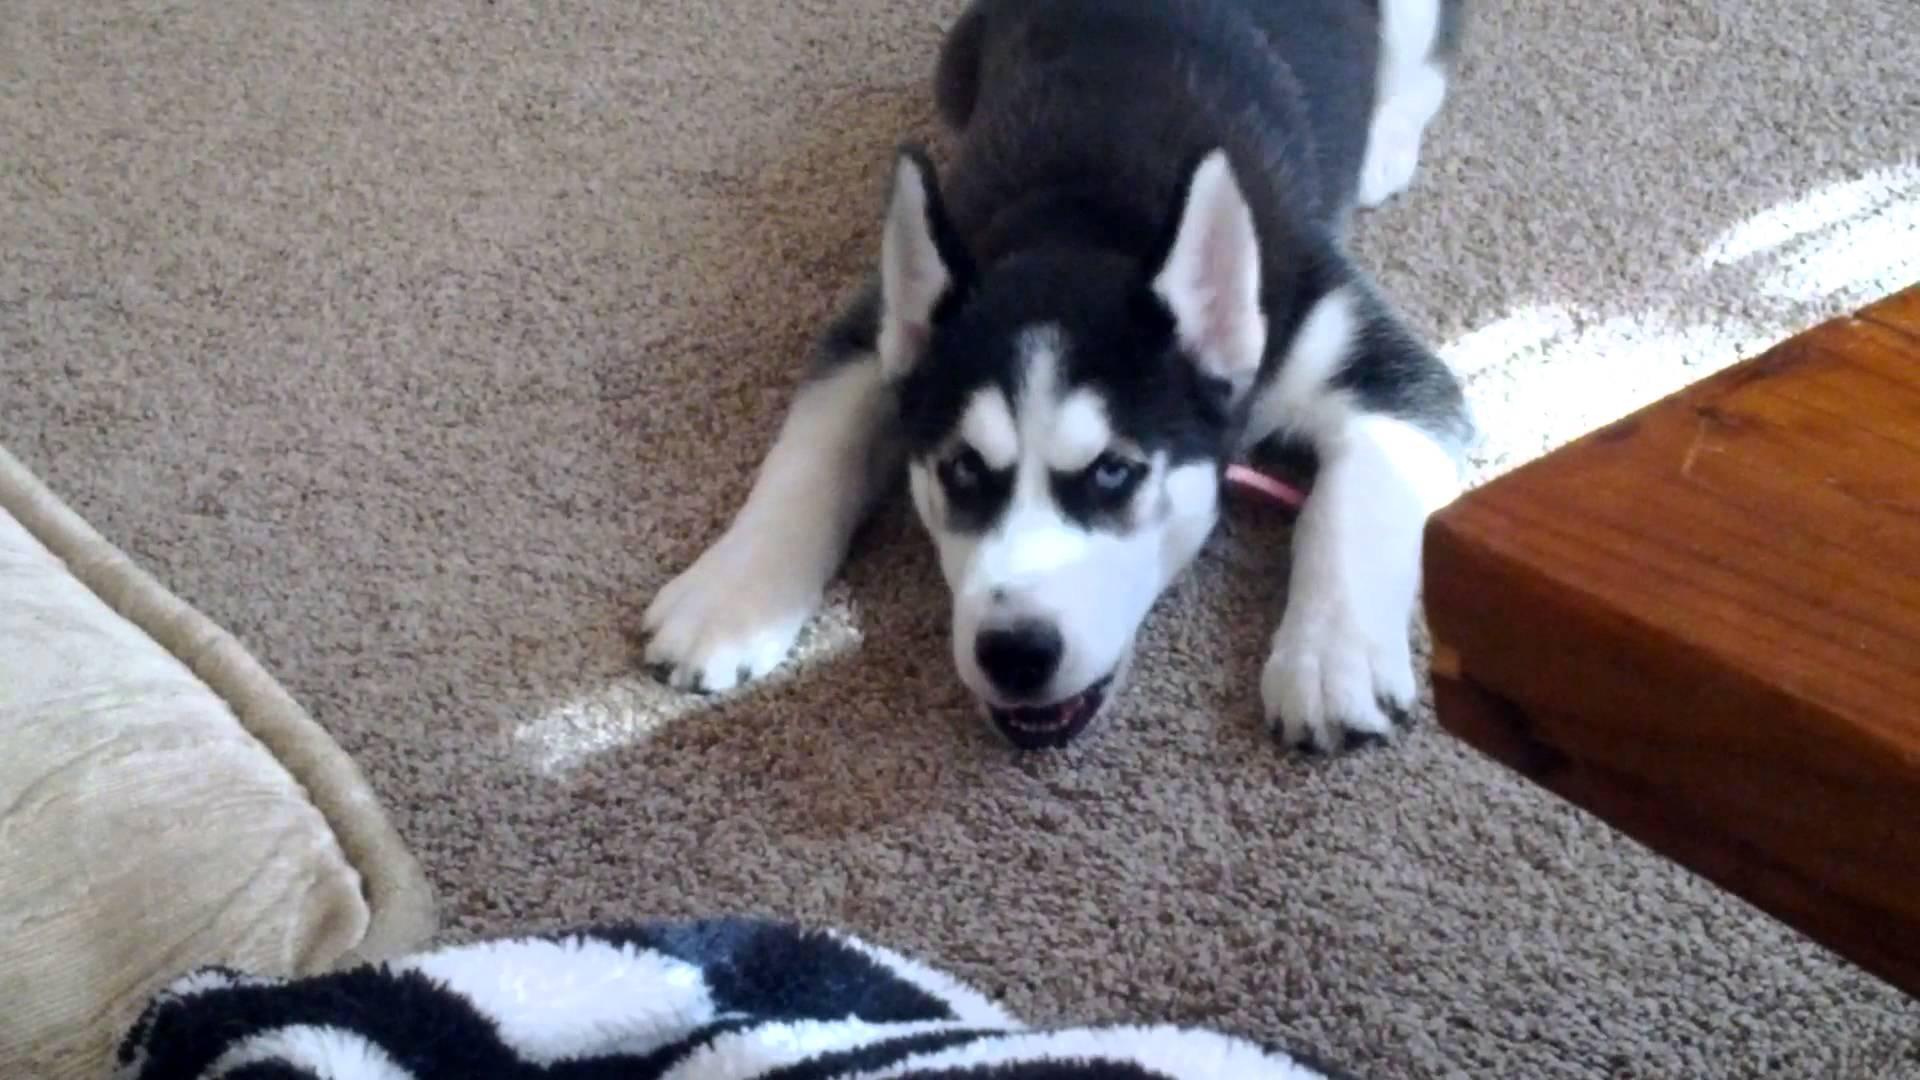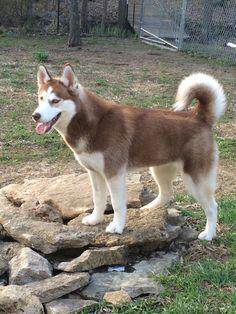The first image is the image on the left, the second image is the image on the right. Evaluate the accuracy of this statement regarding the images: "Each image contains one forward-facing husky in the foreground, at least one dog has blue eyes, and one dog sits upright on green grass.". Is it true? Answer yes or no. No. The first image is the image on the left, the second image is the image on the right. Given the left and right images, does the statement "A dog is sitting in the grass in the image on the left." hold true? Answer yes or no. No. 